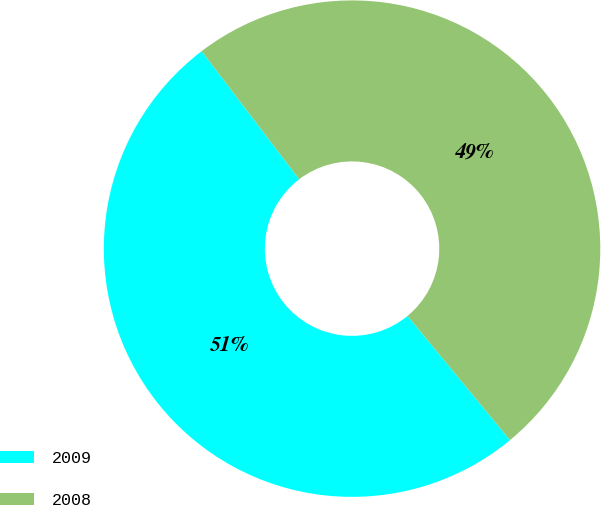Convert chart to OTSL. <chart><loc_0><loc_0><loc_500><loc_500><pie_chart><fcel>2009<fcel>2008<nl><fcel>50.62%<fcel>49.38%<nl></chart> 